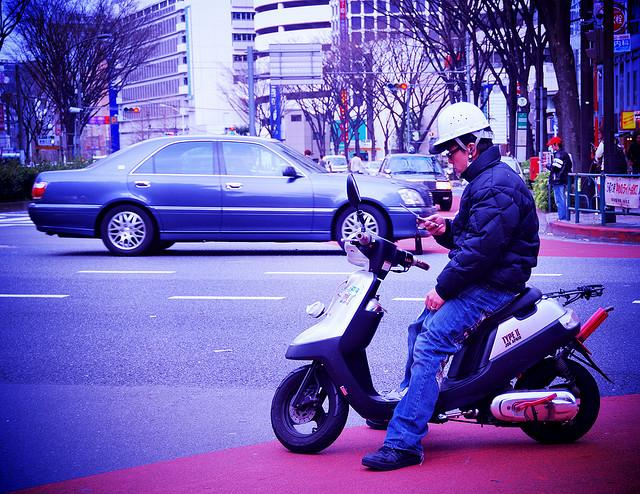In what country is this street found?

Choices:
A) japan
B) north korea
C) south korea
D) china japan 